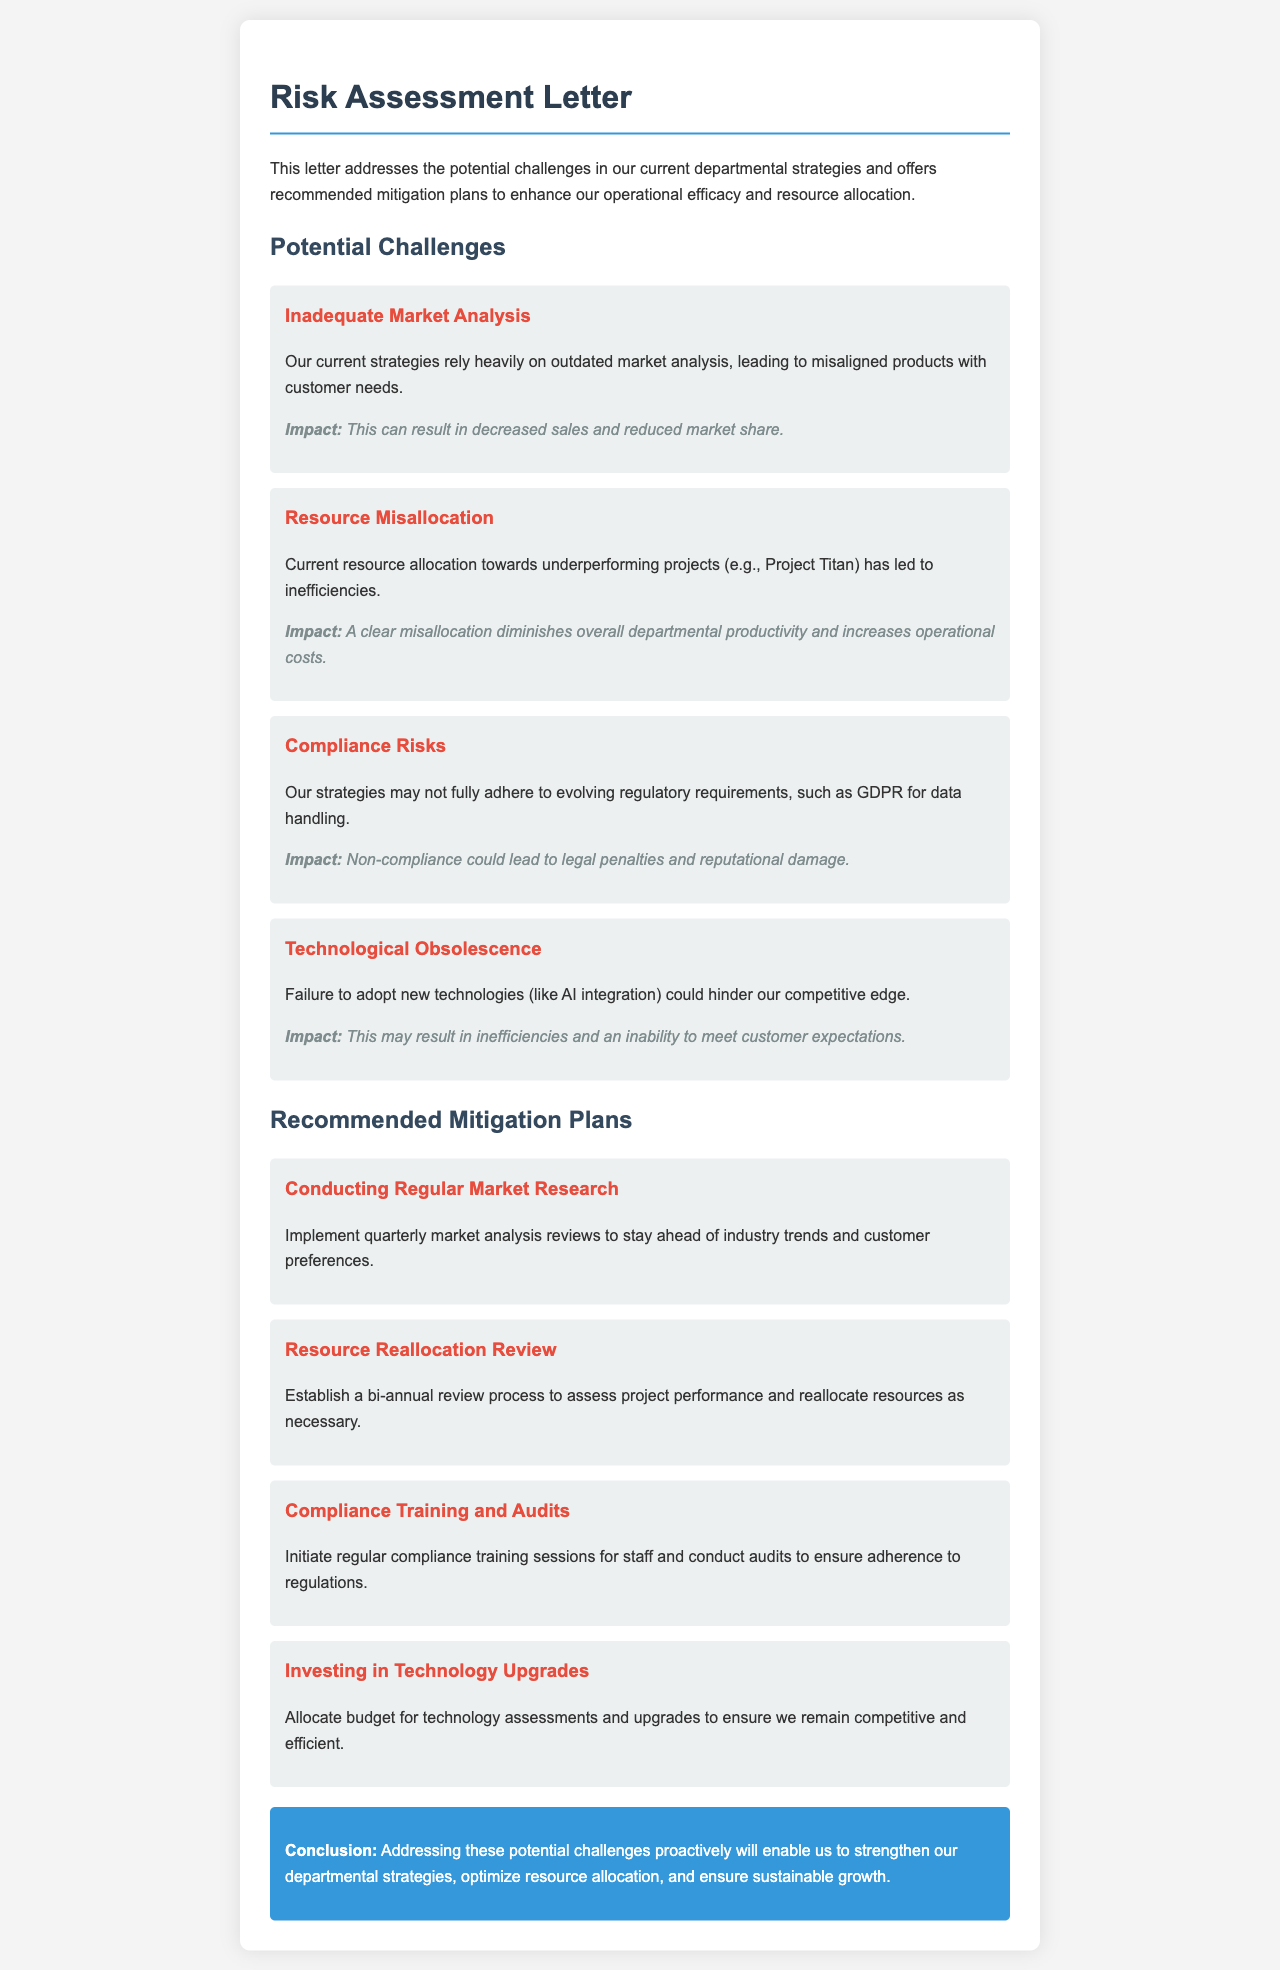What is the title of the document? The title is mentioned at the top of the document and serves as the main heading.
Answer: Risk Assessment Letter What is one potential challenge identified in the document? The challenges section lists several issues that need to be addressed.
Answer: Inadequate Market Analysis What is the impact of resource misallocation? The document states the consequences of misallocation of resources towards underperforming projects.
Answer: Diminishes overall departmental productivity and increases operational costs How often should market research be conducted according to the mitigation plan? The mitigation plans specify the frequency of market analysis reviews.
Answer: Quarterly What is one recommended mitigation plan? The mitigation plans section lists actions to address the identified challenges.
Answer: Conducting Regular Market Research What is the suggested purpose of compliance training? The document explains the objective behind initiating regular compliance training sessions for staff.
Answer: Ensure adherence to regulations How often should resource allocation reviews take place? The mitigation plans section indicates a review process timeline for project performance assessment.
Answer: Bi-annual What could non-compliance lead to? The potential consequences of regulatory non-compliance are outlined in the challenges.
Answer: Legal penalties and reputational damage What is the main conclusion of the letter? The conclusion summarizes the overall message and objective of the document.
Answer: Strengthen our departmental strategies, optimize resource allocation, and ensure sustainable growth 